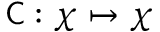<formula> <loc_0><loc_0><loc_500><loc_500>{ C } \colon \chi \mapsto \chi</formula> 